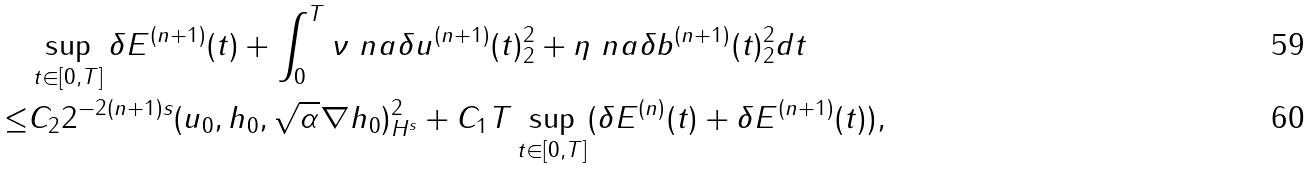<formula> <loc_0><loc_0><loc_500><loc_500>& \sup _ { t \in [ 0 , T ] } \delta E ^ { ( n + 1 ) } ( t ) + \int _ { 0 } ^ { T } \nu \| \ n a \delta u ^ { ( n + 1 ) } ( t ) \| _ { 2 } ^ { 2 } + \eta \| \ n a \delta b ^ { ( n + 1 ) } ( t ) \| _ { 2 } ^ { 2 } d t \\ \leq & C _ { 2 } 2 ^ { - 2 ( n + 1 ) s } \| ( u _ { 0 } , h _ { 0 } , \sqrt { \alpha } \nabla h _ { 0 } ) \| _ { H ^ { s } } ^ { 2 } + C _ { 1 } T \sup _ { t \in [ 0 , T ] } ( \delta E ^ { ( n ) } ( t ) + \delta E ^ { ( n + 1 ) } ( t ) ) ,</formula> 